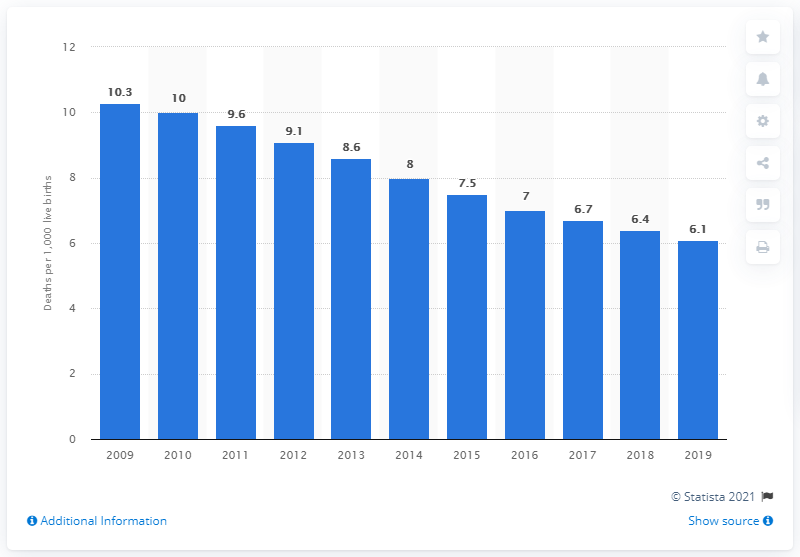Mention a couple of crucial points in this snapshot. In 2019, the infant mortality rate in Sri Lanka was 6.1 deaths per 1,000 live births. 